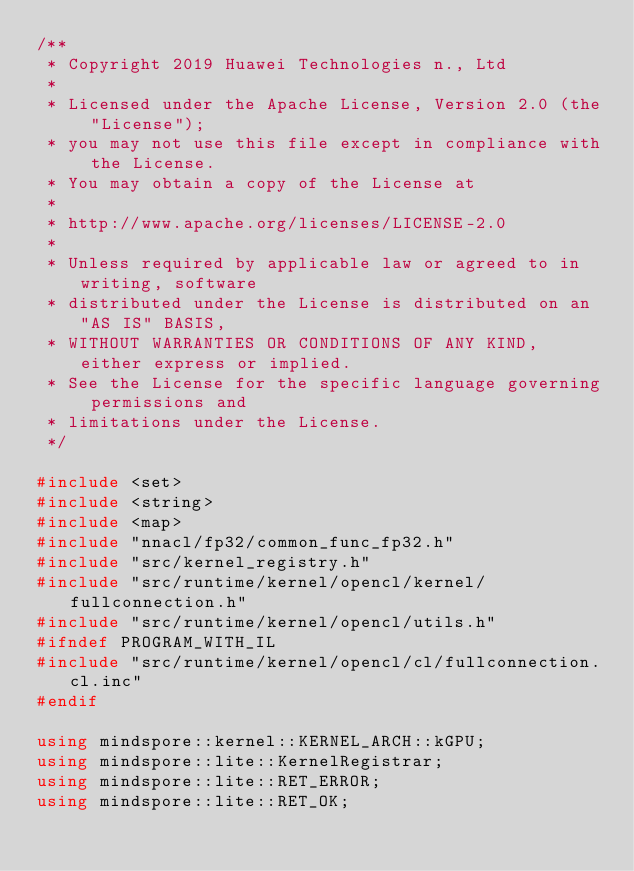Convert code to text. <code><loc_0><loc_0><loc_500><loc_500><_C++_>/**
 * Copyright 2019 Huawei Technologies n., Ltd
 *
 * Licensed under the Apache License, Version 2.0 (the "License");
 * you may not use this file except in compliance with the License.
 * You may obtain a copy of the License at
 *
 * http://www.apache.org/licenses/LICENSE-2.0
 *
 * Unless required by applicable law or agreed to in writing, software
 * distributed under the License is distributed on an "AS IS" BASIS,
 * WITHOUT WARRANTIES OR CONDITIONS OF ANY KIND, either express or implied.
 * See the License for the specific language governing permissions and
 * limitations under the License.
 */

#include <set>
#include <string>
#include <map>
#include "nnacl/fp32/common_func_fp32.h"
#include "src/kernel_registry.h"
#include "src/runtime/kernel/opencl/kernel/fullconnection.h"
#include "src/runtime/kernel/opencl/utils.h"
#ifndef PROGRAM_WITH_IL
#include "src/runtime/kernel/opencl/cl/fullconnection.cl.inc"
#endif

using mindspore::kernel::KERNEL_ARCH::kGPU;
using mindspore::lite::KernelRegistrar;
using mindspore::lite::RET_ERROR;
using mindspore::lite::RET_OK;</code> 